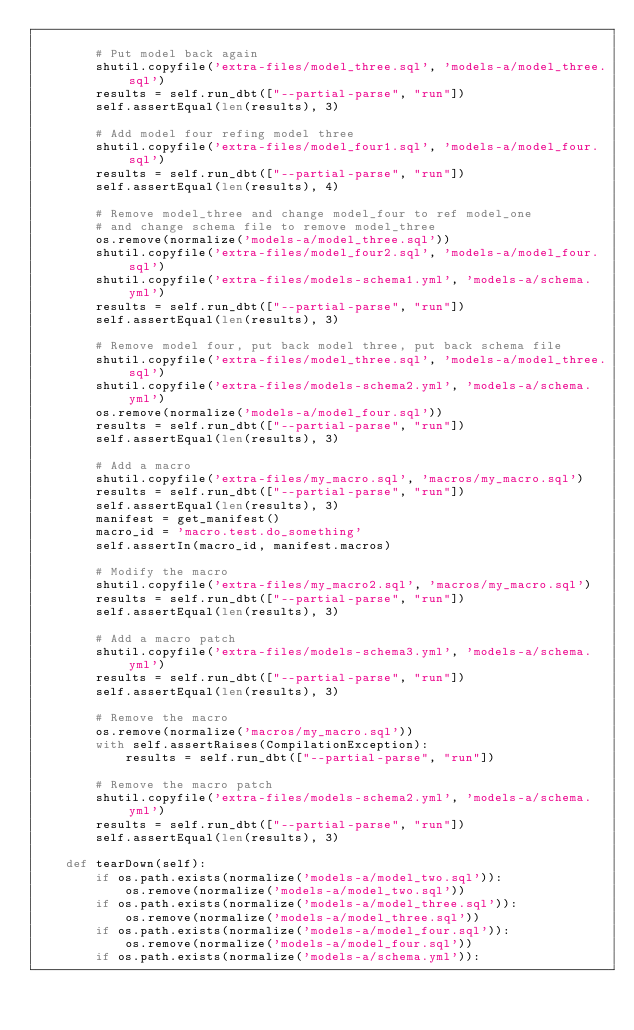<code> <loc_0><loc_0><loc_500><loc_500><_Python_>
        # Put model back again
        shutil.copyfile('extra-files/model_three.sql', 'models-a/model_three.sql')
        results = self.run_dbt(["--partial-parse", "run"])
        self.assertEqual(len(results), 3)

        # Add model four refing model three
        shutil.copyfile('extra-files/model_four1.sql', 'models-a/model_four.sql')
        results = self.run_dbt(["--partial-parse", "run"])
        self.assertEqual(len(results), 4)

        # Remove model_three and change model_four to ref model_one
        # and change schema file to remove model_three
        os.remove(normalize('models-a/model_three.sql'))
        shutil.copyfile('extra-files/model_four2.sql', 'models-a/model_four.sql')
        shutil.copyfile('extra-files/models-schema1.yml', 'models-a/schema.yml')
        results = self.run_dbt(["--partial-parse", "run"])
        self.assertEqual(len(results), 3)

        # Remove model four, put back model three, put back schema file
        shutil.copyfile('extra-files/model_three.sql', 'models-a/model_three.sql')
        shutil.copyfile('extra-files/models-schema2.yml', 'models-a/schema.yml')
        os.remove(normalize('models-a/model_four.sql'))
        results = self.run_dbt(["--partial-parse", "run"])
        self.assertEqual(len(results), 3)

        # Add a macro
        shutil.copyfile('extra-files/my_macro.sql', 'macros/my_macro.sql')
        results = self.run_dbt(["--partial-parse", "run"])
        self.assertEqual(len(results), 3)
        manifest = get_manifest()
        macro_id = 'macro.test.do_something'
        self.assertIn(macro_id, manifest.macros)

        # Modify the macro
        shutil.copyfile('extra-files/my_macro2.sql', 'macros/my_macro.sql')
        results = self.run_dbt(["--partial-parse", "run"])
        self.assertEqual(len(results), 3)

        # Add a macro patch
        shutil.copyfile('extra-files/models-schema3.yml', 'models-a/schema.yml')
        results = self.run_dbt(["--partial-parse", "run"])
        self.assertEqual(len(results), 3)

        # Remove the macro
        os.remove(normalize('macros/my_macro.sql'))
        with self.assertRaises(CompilationException):
            results = self.run_dbt(["--partial-parse", "run"])

        # Remove the macro patch
        shutil.copyfile('extra-files/models-schema2.yml', 'models-a/schema.yml')
        results = self.run_dbt(["--partial-parse", "run"])
        self.assertEqual(len(results), 3)

    def tearDown(self):
        if os.path.exists(normalize('models-a/model_two.sql')):
            os.remove(normalize('models-a/model_two.sql'))
        if os.path.exists(normalize('models-a/model_three.sql')):
            os.remove(normalize('models-a/model_three.sql'))
        if os.path.exists(normalize('models-a/model_four.sql')):
            os.remove(normalize('models-a/model_four.sql'))
        if os.path.exists(normalize('models-a/schema.yml')):</code> 